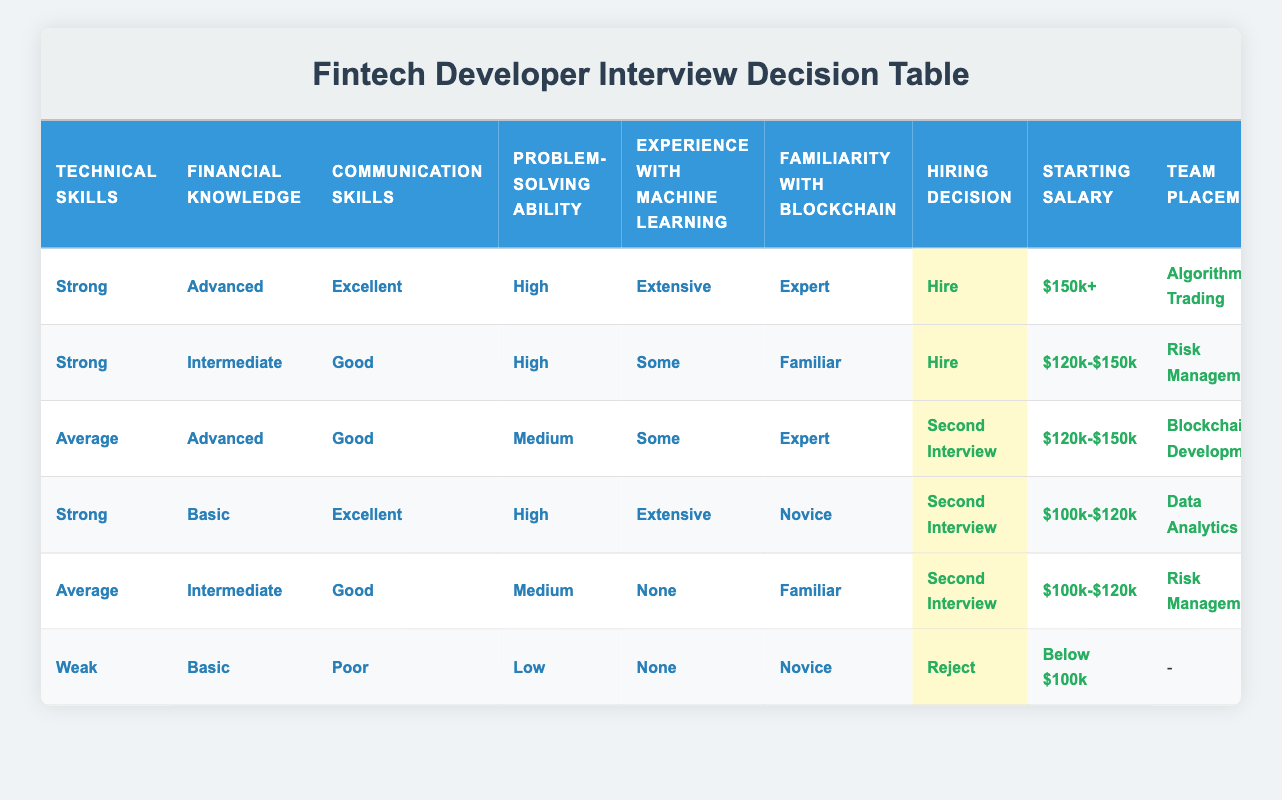What is the hiring decision for candidates with strong technical skills and advanced financial knowledge? According to the table, candidates with "Strong" technical skills and "Advanced" financial knowledge are hired with a starting salary of "$150k+" and placed in "Algorithmic Trading" with "Minimal" training requirements.
Answer: Hire How many roles in the table require moderate training? There are 3 rows that indicate "Moderate" training requirements: one for "Risk Management" with "Strong" technical skills and "Intermediate" financial knowledge, one for "Blockchain Development" with "Average" technical skills and "Advanced" financial knowledge, and one for "Data Analytics" with "Strong" technical skills and "Basic" financial knowledge. Thus, the total count is 3.
Answer: 3 Do candidates with weak communication skills ever get hired? In the table, there is no row where candidates with "Poor" communication skills are hired; the only outcome for candidates with weak skills is a rejection. Therefore, the answer is no.
Answer: No Which position has the highest starting salary, and what are its conditions? The position with the highest starting salary is "Algorithmic Trading," which has the conditions: "Strong" technical skills, "Advanced" financial knowledge, "Excellent" communication skills, "High" problem-solving ability, "Extensive" experience with machine learning, and "Expert" familiarity with blockchain.
Answer: Algorithmic Trading What is the average starting salary for candidates who receive a second interview? The candidates who receive a second interview are associated with salaries of "$120k-$150k" and "$100k-$120k". There are 4 candidates: 2 with "$120k-$150k" and 2 with "$100k-$120k". The total is ($120k + $120k + $100k + $100k) = $440k. Dividing by 4 gives an average salary of $110k.
Answer: $110k If a candidate has weak financial knowledge, what will likely be their hiring decision? The candidates with "Weak" financial knowledge are associated with "Basic" financial knowledge along with "Poor" communication skills and are rejected according to the table. Thus, the likely decision is to reject them.
Answer: Reject Which department has the candidate with the highest technical skills but basic financial knowledge? The department assigned to the candidate with "Strong" technical skills, "Basic" financial knowledge, "Excellent" communication skills, "High" problem-solving ability, "Extensive" experience with machine learning, and "Novice" familiarity with blockchain is "Data Analytics."
Answer: Data Analytics Are there any candidates in the table who are familiar with blockchain but have no experience with machine learning? Yes, there is one candidate with "Average" technical skills, "Intermediate" financial knowledge, "Good" communication skills, "Medium" problem-solving ability, "None" for experience with machine learning, and "Familiar" with blockchain. Thus, there is at least one candidate meeting those criteria.
Answer: Yes 